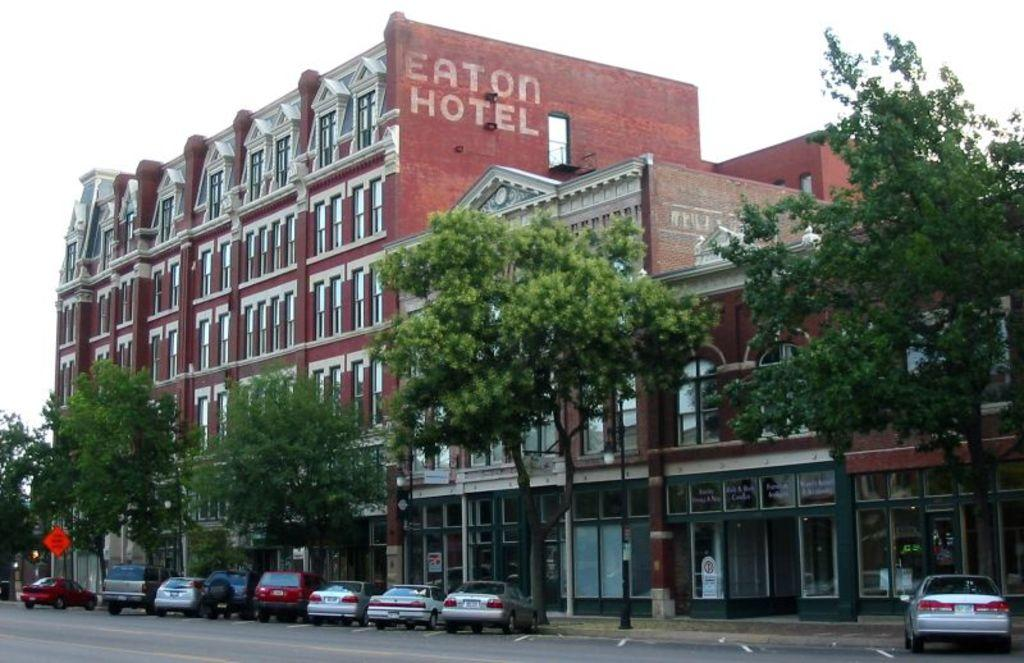What type of structures can be seen in the image? There are buildings in the image. What feature of the buildings is visible? There are windows visible in the image. What mode of transportation can be seen on the road in the image? Vehicles are present on the road in the image. What type of information might be conveyed by the sign board in the image? The sign board in the image might convey information about directions, advertisements, or warnings. What is the purpose of the pole in the image? The pole in the image might be used for supporting electrical wires, streetlights, or signage. What type of natural elements can be seen in the image? Trees are visible in the image. What part of the natural environment is visible in the image? The sky is visible in the image. How does the cow feel about the turn signal on the vehicle in the image? There is no cow present in the image, so it is not possible to determine how a cow might feel about the turn signal on a vehicle. 